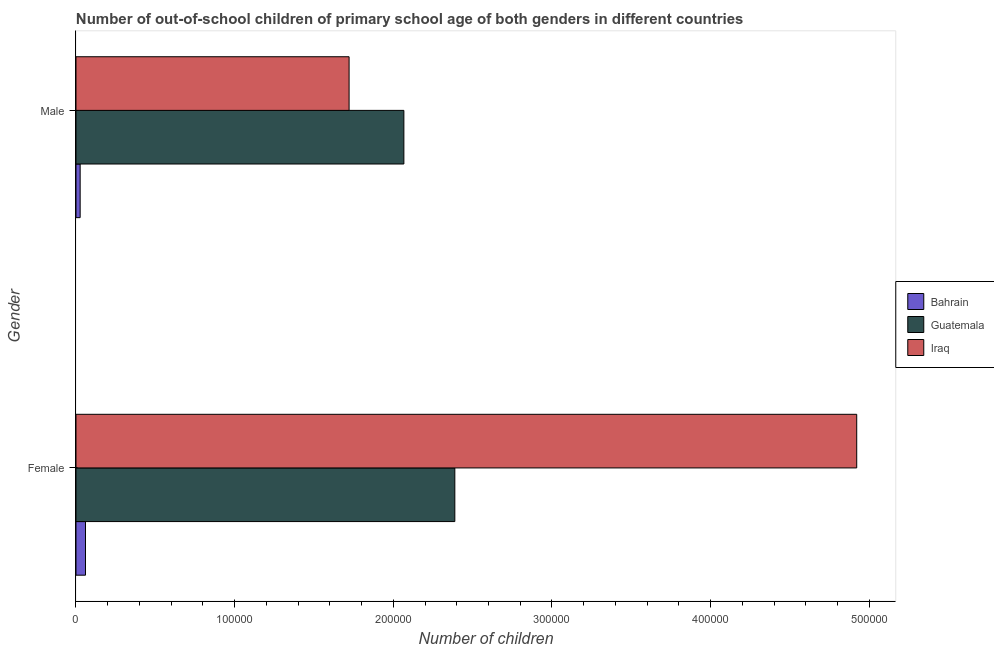How many different coloured bars are there?
Your response must be concise. 3. How many groups of bars are there?
Your answer should be very brief. 2. Are the number of bars per tick equal to the number of legend labels?
Your response must be concise. Yes. Are the number of bars on each tick of the Y-axis equal?
Provide a short and direct response. Yes. How many bars are there on the 2nd tick from the top?
Ensure brevity in your answer.  3. What is the number of female out-of-school students in Iraq?
Ensure brevity in your answer.  4.92e+05. Across all countries, what is the maximum number of male out-of-school students?
Ensure brevity in your answer.  2.07e+05. Across all countries, what is the minimum number of female out-of-school students?
Provide a short and direct response. 5991. In which country was the number of male out-of-school students maximum?
Give a very brief answer. Guatemala. In which country was the number of male out-of-school students minimum?
Your answer should be very brief. Bahrain. What is the total number of male out-of-school students in the graph?
Your answer should be compact. 3.81e+05. What is the difference between the number of female out-of-school students in Bahrain and that in Iraq?
Make the answer very short. -4.86e+05. What is the difference between the number of female out-of-school students in Guatemala and the number of male out-of-school students in Iraq?
Offer a very short reply. 6.66e+04. What is the average number of female out-of-school students per country?
Keep it short and to the point. 2.46e+05. What is the difference between the number of female out-of-school students and number of male out-of-school students in Iraq?
Provide a succinct answer. 3.20e+05. In how many countries, is the number of male out-of-school students greater than 260000 ?
Offer a very short reply. 0. What is the ratio of the number of male out-of-school students in Iraq to that in Bahrain?
Give a very brief answer. 65.45. What does the 1st bar from the top in Female represents?
Make the answer very short. Iraq. What does the 1st bar from the bottom in Male represents?
Your answer should be very brief. Bahrain. Are the values on the major ticks of X-axis written in scientific E-notation?
Offer a very short reply. No. What is the title of the graph?
Your answer should be very brief. Number of out-of-school children of primary school age of both genders in different countries. Does "Slovak Republic" appear as one of the legend labels in the graph?
Provide a short and direct response. No. What is the label or title of the X-axis?
Provide a succinct answer. Number of children. What is the Number of children in Bahrain in Female?
Keep it short and to the point. 5991. What is the Number of children in Guatemala in Female?
Your response must be concise. 2.39e+05. What is the Number of children in Iraq in Female?
Make the answer very short. 4.92e+05. What is the Number of children of Bahrain in Male?
Provide a short and direct response. 2630. What is the Number of children of Guatemala in Male?
Your answer should be compact. 2.07e+05. What is the Number of children of Iraq in Male?
Provide a succinct answer. 1.72e+05. Across all Gender, what is the maximum Number of children in Bahrain?
Ensure brevity in your answer.  5991. Across all Gender, what is the maximum Number of children of Guatemala?
Your answer should be very brief. 2.39e+05. Across all Gender, what is the maximum Number of children in Iraq?
Provide a succinct answer. 4.92e+05. Across all Gender, what is the minimum Number of children of Bahrain?
Keep it short and to the point. 2630. Across all Gender, what is the minimum Number of children of Guatemala?
Make the answer very short. 2.07e+05. Across all Gender, what is the minimum Number of children in Iraq?
Your answer should be very brief. 1.72e+05. What is the total Number of children of Bahrain in the graph?
Your answer should be compact. 8621. What is the total Number of children in Guatemala in the graph?
Provide a succinct answer. 4.45e+05. What is the total Number of children of Iraq in the graph?
Keep it short and to the point. 6.64e+05. What is the difference between the Number of children in Bahrain in Female and that in Male?
Your answer should be compact. 3361. What is the difference between the Number of children of Guatemala in Female and that in Male?
Provide a short and direct response. 3.21e+04. What is the difference between the Number of children of Iraq in Female and that in Male?
Provide a succinct answer. 3.20e+05. What is the difference between the Number of children in Bahrain in Female and the Number of children in Guatemala in Male?
Provide a succinct answer. -2.01e+05. What is the difference between the Number of children in Bahrain in Female and the Number of children in Iraq in Male?
Ensure brevity in your answer.  -1.66e+05. What is the difference between the Number of children of Guatemala in Female and the Number of children of Iraq in Male?
Your answer should be compact. 6.66e+04. What is the average Number of children in Bahrain per Gender?
Keep it short and to the point. 4310.5. What is the average Number of children of Guatemala per Gender?
Your answer should be compact. 2.23e+05. What is the average Number of children in Iraq per Gender?
Your response must be concise. 3.32e+05. What is the difference between the Number of children of Bahrain and Number of children of Guatemala in Female?
Provide a short and direct response. -2.33e+05. What is the difference between the Number of children in Bahrain and Number of children in Iraq in Female?
Give a very brief answer. -4.86e+05. What is the difference between the Number of children of Guatemala and Number of children of Iraq in Female?
Your answer should be compact. -2.53e+05. What is the difference between the Number of children in Bahrain and Number of children in Guatemala in Male?
Provide a short and direct response. -2.04e+05. What is the difference between the Number of children in Bahrain and Number of children in Iraq in Male?
Your answer should be very brief. -1.70e+05. What is the difference between the Number of children in Guatemala and Number of children in Iraq in Male?
Provide a succinct answer. 3.45e+04. What is the ratio of the Number of children of Bahrain in Female to that in Male?
Ensure brevity in your answer.  2.28. What is the ratio of the Number of children of Guatemala in Female to that in Male?
Offer a terse response. 1.16. What is the ratio of the Number of children in Iraq in Female to that in Male?
Your answer should be very brief. 2.86. What is the difference between the highest and the second highest Number of children of Bahrain?
Offer a terse response. 3361. What is the difference between the highest and the second highest Number of children of Guatemala?
Keep it short and to the point. 3.21e+04. What is the difference between the highest and the second highest Number of children of Iraq?
Make the answer very short. 3.20e+05. What is the difference between the highest and the lowest Number of children in Bahrain?
Offer a very short reply. 3361. What is the difference between the highest and the lowest Number of children of Guatemala?
Offer a very short reply. 3.21e+04. What is the difference between the highest and the lowest Number of children in Iraq?
Provide a succinct answer. 3.20e+05. 